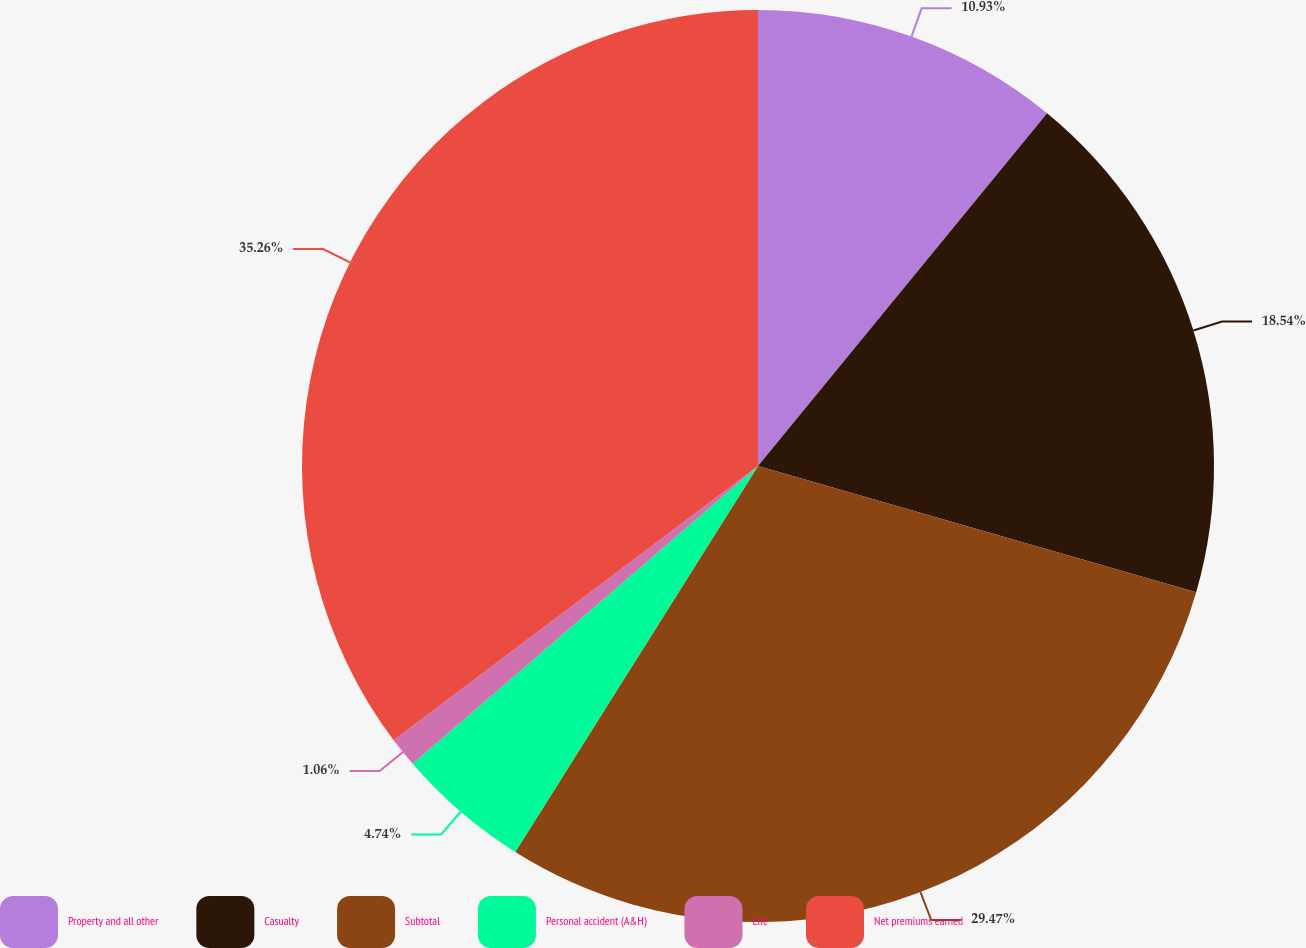Convert chart. <chart><loc_0><loc_0><loc_500><loc_500><pie_chart><fcel>Property and all other<fcel>Casualty<fcel>Subtotal<fcel>Personal accident (A&H)<fcel>Life<fcel>Net premiums earned<nl><fcel>10.93%<fcel>18.54%<fcel>29.47%<fcel>4.74%<fcel>1.06%<fcel>35.27%<nl></chart> 